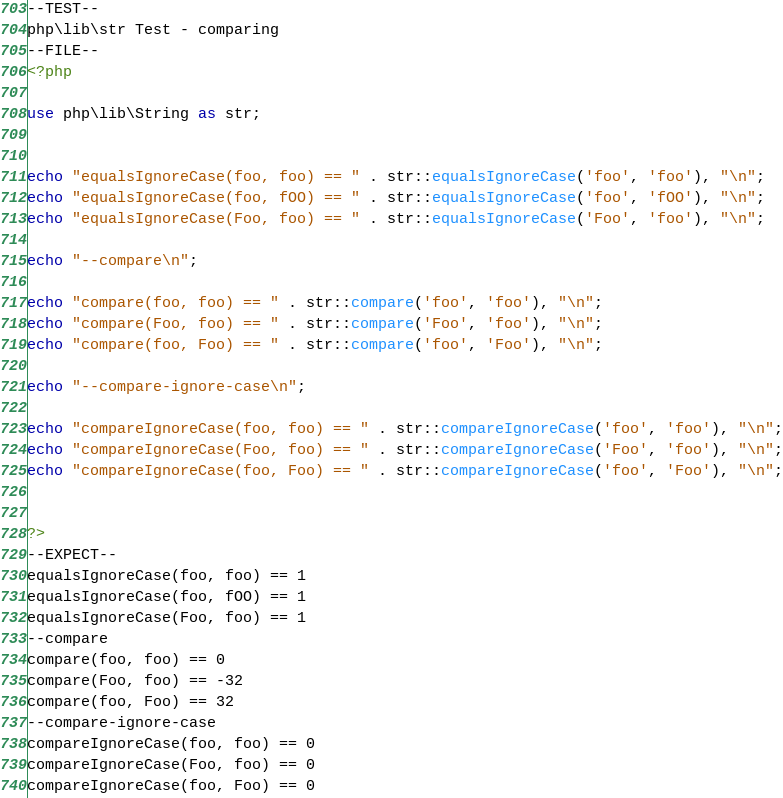Convert code to text. <code><loc_0><loc_0><loc_500><loc_500><_PHP_>--TEST--
php\lib\str Test - comparing
--FILE--
<?php

use php\lib\String as str;


echo "equalsIgnoreCase(foo, foo) == " . str::equalsIgnoreCase('foo', 'foo'), "\n";
echo "equalsIgnoreCase(foo, fOO) == " . str::equalsIgnoreCase('foo', 'fOO'), "\n";
echo "equalsIgnoreCase(Foo, foo) == " . str::equalsIgnoreCase('Foo', 'foo'), "\n";

echo "--compare\n";

echo "compare(foo, foo) == " . str::compare('foo', 'foo'), "\n";
echo "compare(Foo, foo) == " . str::compare('Foo', 'foo'), "\n";
echo "compare(foo, Foo) == " . str::compare('foo', 'Foo'), "\n";

echo "--compare-ignore-case\n";

echo "compareIgnoreCase(foo, foo) == " . str::compareIgnoreCase('foo', 'foo'), "\n";
echo "compareIgnoreCase(Foo, foo) == " . str::compareIgnoreCase('Foo', 'foo'), "\n";
echo "compareIgnoreCase(foo, Foo) == " . str::compareIgnoreCase('foo', 'Foo'), "\n";


?>
--EXPECT--
equalsIgnoreCase(foo, foo) == 1
equalsIgnoreCase(foo, fOO) == 1
equalsIgnoreCase(Foo, foo) == 1
--compare
compare(foo, foo) == 0
compare(Foo, foo) == -32
compare(foo, Foo) == 32
--compare-ignore-case
compareIgnoreCase(foo, foo) == 0
compareIgnoreCase(Foo, foo) == 0
compareIgnoreCase(foo, Foo) == 0
</code> 